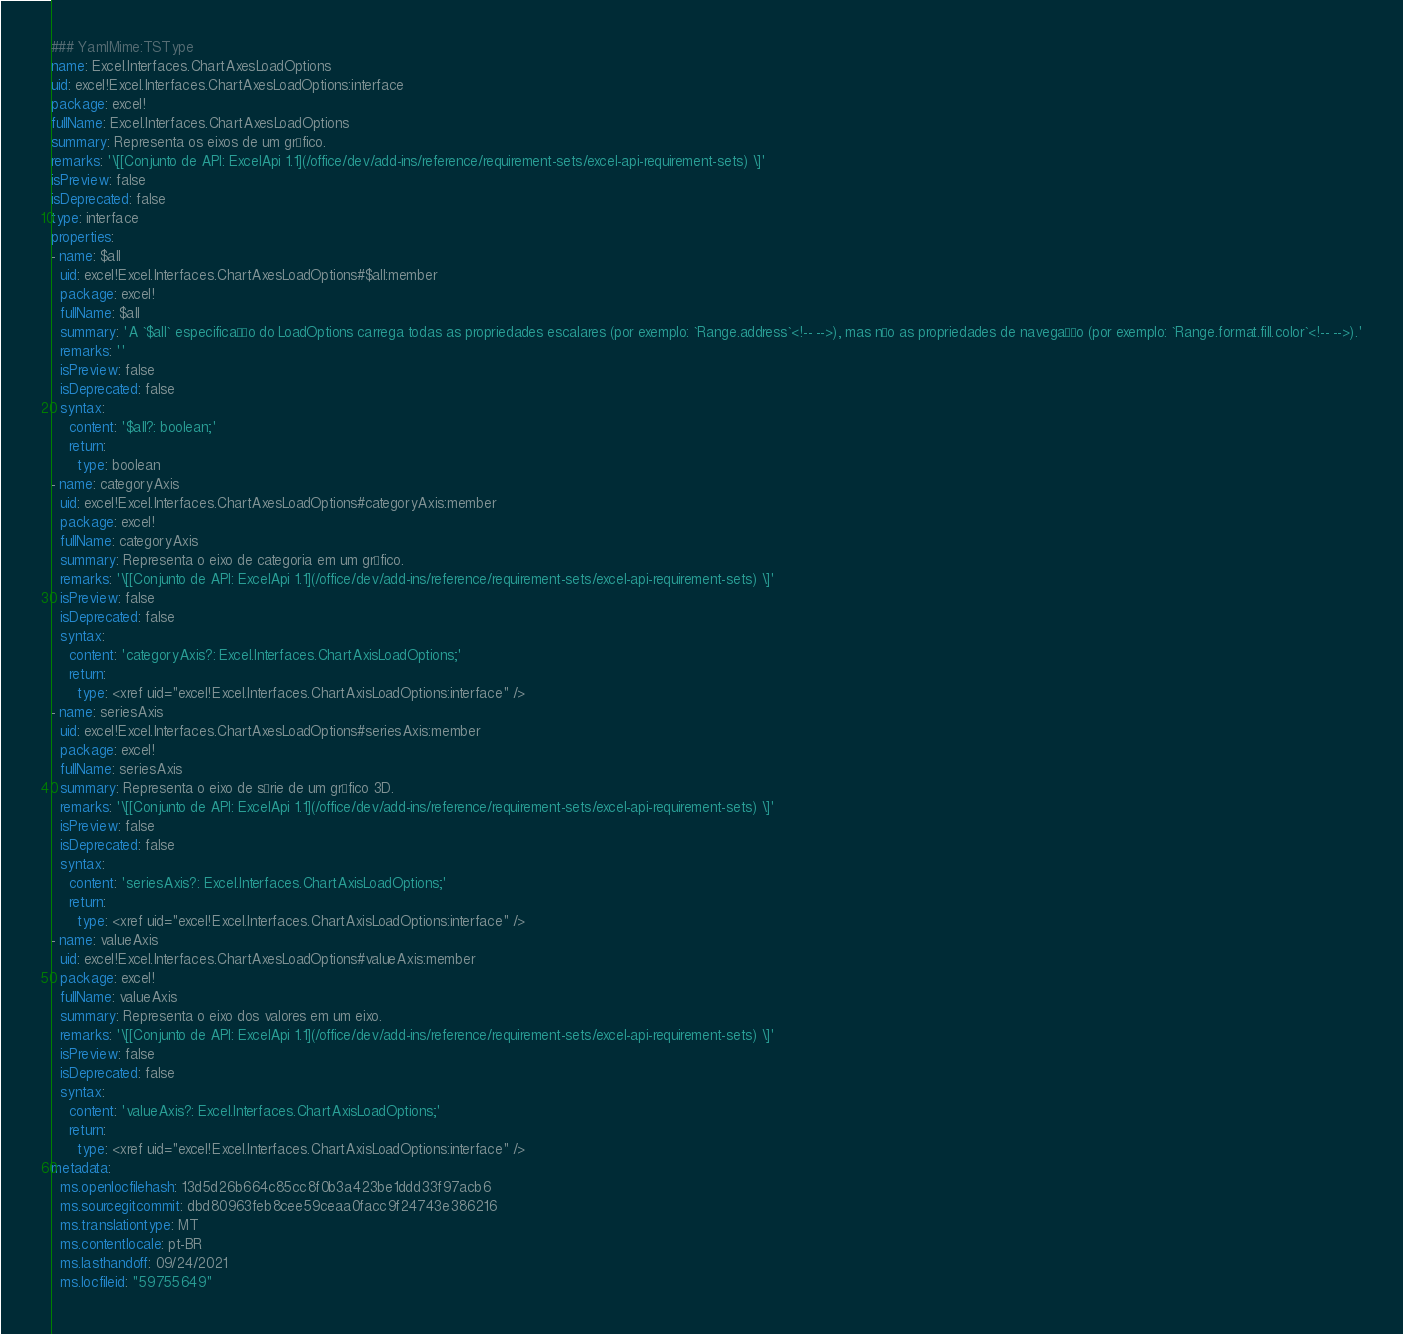Convert code to text. <code><loc_0><loc_0><loc_500><loc_500><_YAML_>### YamlMime:TSType
name: Excel.Interfaces.ChartAxesLoadOptions
uid: excel!Excel.Interfaces.ChartAxesLoadOptions:interface
package: excel!
fullName: Excel.Interfaces.ChartAxesLoadOptions
summary: Representa os eixos de um gráfico.
remarks: '\[[Conjunto de API: ExcelApi 1.1](/office/dev/add-ins/reference/requirement-sets/excel-api-requirement-sets) \]'
isPreview: false
isDeprecated: false
type: interface
properties:
- name: $all
  uid: excel!Excel.Interfaces.ChartAxesLoadOptions#$all:member
  package: excel!
  fullName: $all
  summary: 'A `$all` especificação do LoadOptions carrega todas as propriedades escalares (por exemplo: `Range.address`<!-- -->), mas não as propriedades de navegação (por exemplo: `Range.format.fill.color`<!-- -->).'
  remarks: ''
  isPreview: false
  isDeprecated: false
  syntax:
    content: '$all?: boolean;'
    return:
      type: boolean
- name: categoryAxis
  uid: excel!Excel.Interfaces.ChartAxesLoadOptions#categoryAxis:member
  package: excel!
  fullName: categoryAxis
  summary: Representa o eixo de categoria em um gráfico.
  remarks: '\[[Conjunto de API: ExcelApi 1.1](/office/dev/add-ins/reference/requirement-sets/excel-api-requirement-sets) \]'
  isPreview: false
  isDeprecated: false
  syntax:
    content: 'categoryAxis?: Excel.Interfaces.ChartAxisLoadOptions;'
    return:
      type: <xref uid="excel!Excel.Interfaces.ChartAxisLoadOptions:interface" />
- name: seriesAxis
  uid: excel!Excel.Interfaces.ChartAxesLoadOptions#seriesAxis:member
  package: excel!
  fullName: seriesAxis
  summary: Representa o eixo de série de um gráfico 3D.
  remarks: '\[[Conjunto de API: ExcelApi 1.1](/office/dev/add-ins/reference/requirement-sets/excel-api-requirement-sets) \]'
  isPreview: false
  isDeprecated: false
  syntax:
    content: 'seriesAxis?: Excel.Interfaces.ChartAxisLoadOptions;'
    return:
      type: <xref uid="excel!Excel.Interfaces.ChartAxisLoadOptions:interface" />
- name: valueAxis
  uid: excel!Excel.Interfaces.ChartAxesLoadOptions#valueAxis:member
  package: excel!
  fullName: valueAxis
  summary: Representa o eixo dos valores em um eixo.
  remarks: '\[[Conjunto de API: ExcelApi 1.1](/office/dev/add-ins/reference/requirement-sets/excel-api-requirement-sets) \]'
  isPreview: false
  isDeprecated: false
  syntax:
    content: 'valueAxis?: Excel.Interfaces.ChartAxisLoadOptions;'
    return:
      type: <xref uid="excel!Excel.Interfaces.ChartAxisLoadOptions:interface" />
metadata:
  ms.openlocfilehash: 13d5d26b664c85cc8f0b3a423be1ddd33f97acb6
  ms.sourcegitcommit: dbd80963feb8cee59ceaa0facc9f24743e386216
  ms.translationtype: MT
  ms.contentlocale: pt-BR
  ms.lasthandoff: 09/24/2021
  ms.locfileid: "59755649"
</code> 